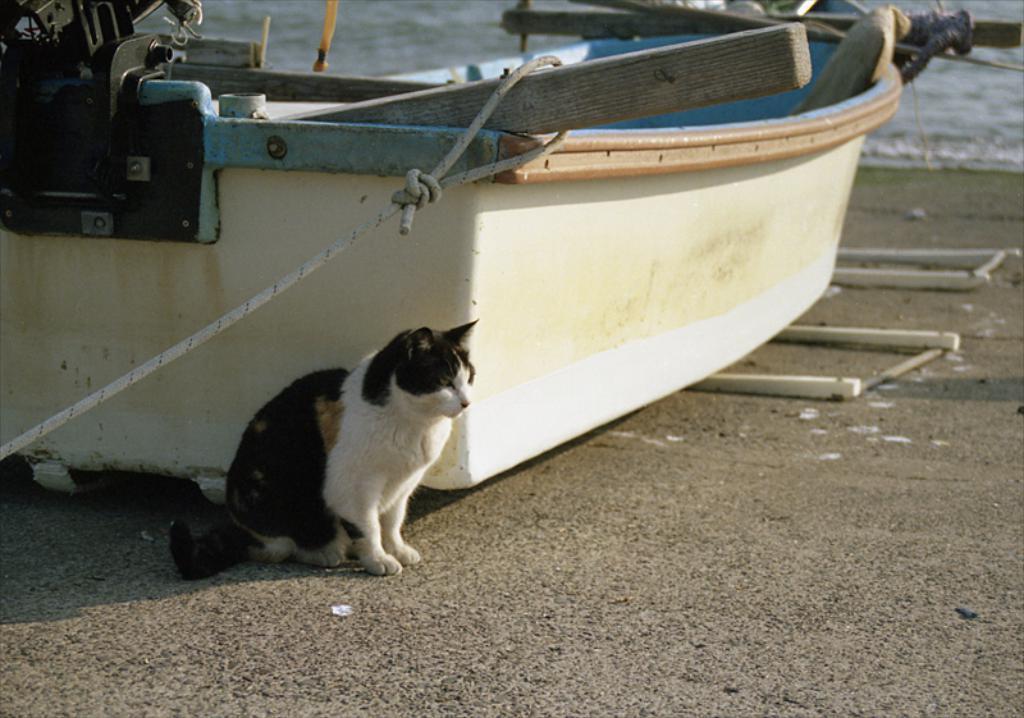How would you summarize this image in a sentence or two? In this image we can see a cat sitting beside the boat on the seashore. In the background there is sea. 